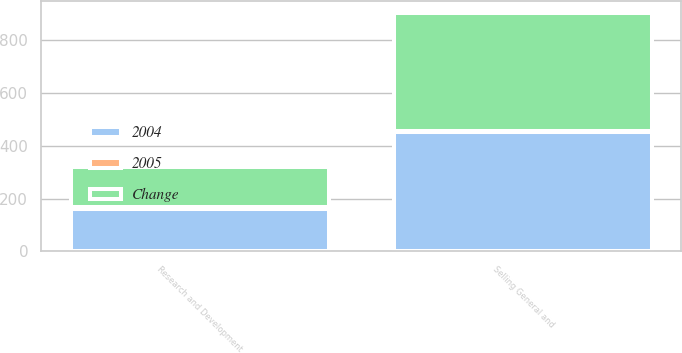Convert chart. <chart><loc_0><loc_0><loc_500><loc_500><stacked_bar_chart><ecel><fcel>Selling General and<fcel>Research and Development<nl><fcel>2004<fcel>454<fcel>162<nl><fcel>Change<fcel>450<fcel>154<nl><fcel>2005<fcel>1<fcel>5<nl></chart> 